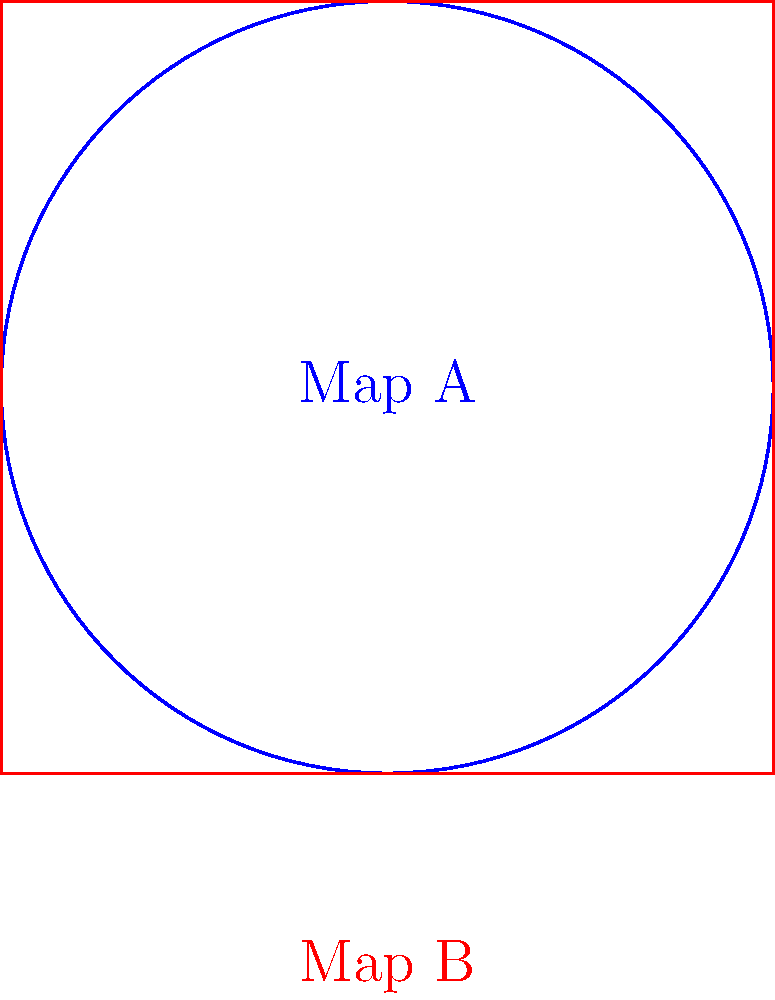Consider two game map layouts: Map A (blue circle) and Map B (red square). Are these maps homotopy equivalent? If so, describe a continuous deformation from one to the other. How might this affect the statistical analysis of player movements in these layouts? To determine if the two map layouts are homotopy equivalent, we need to follow these steps:

1. Understand homotopy equivalence: Two spaces are homotopy equivalent if one can be continuously deformed into the other without tearing or gluing.

2. Analyze the topological properties:
   a) Map A (circle) is a closed curve with no holes.
   b) Map B (square) is also a closed curve with no holes.

3. Consider the deformation:
   a) We can continuously deform the circle into the square by "squaring" the circle.
   b) This deformation doesn't create or remove any holes.

4. Conclude homotopy equivalence: Since we can continuously deform one shape into the other without changing their fundamental topological properties, they are homotopy equivalent.

5. Impact on statistical analysis:
   a) Player movement patterns might be similar in both layouts due to the topological equivalence.
   b) However, the corners in Map B might create "choke points" that don't exist in Map A.
   c) The circular nature of Map A might lead to more uniform distribution of player positions.
   d) Map B might show clustered statistics around corners and edges.

6. Statistical considerations:
   a) Heat maps of player positions might show different patterns despite topological equivalence.
   b) Average player speed might be affected by the presence of corners in Map B.
   c) The frequency of player encounters might differ due to the different geometries.

In conclusion, while the maps are homotopy equivalent, their geometric differences could lead to distinct statistical patterns in player behavior.
Answer: Yes, homotopy equivalent. Continuous deformation: circle to square. Statistical impact: similar overall patterns, but potential differences in player distribution and movement due to geometric features. 